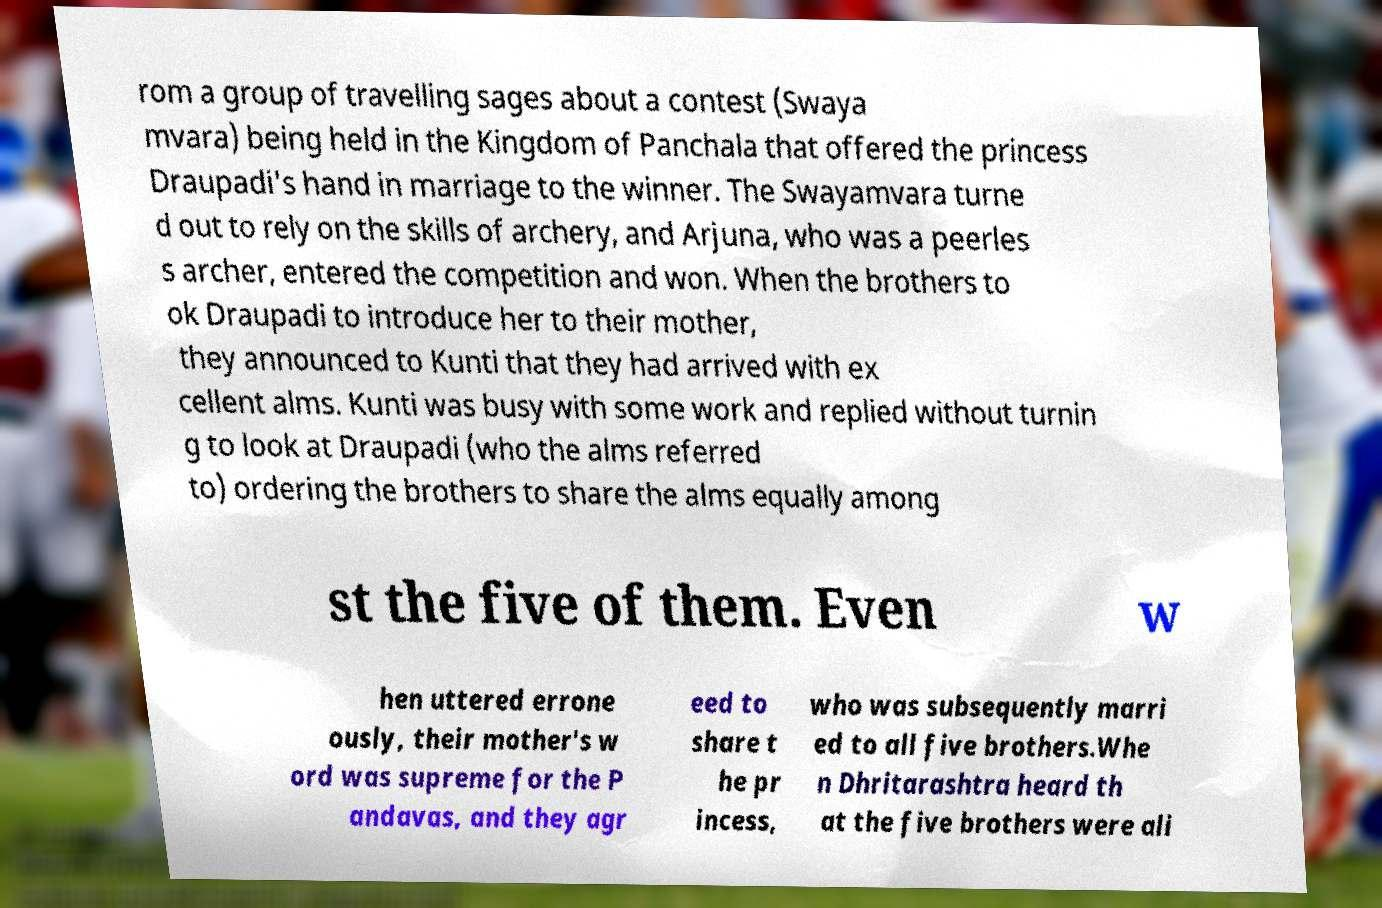Could you assist in decoding the text presented in this image and type it out clearly? rom a group of travelling sages about a contest (Swaya mvara) being held in the Kingdom of Panchala that offered the princess Draupadi's hand in marriage to the winner. The Swayamvara turne d out to rely on the skills of archery, and Arjuna, who was a peerles s archer, entered the competition and won. When the brothers to ok Draupadi to introduce her to their mother, they announced to Kunti that they had arrived with ex cellent alms. Kunti was busy with some work and replied without turnin g to look at Draupadi (who the alms referred to) ordering the brothers to share the alms equally among st the five of them. Even w hen uttered errone ously, their mother's w ord was supreme for the P andavas, and they agr eed to share t he pr incess, who was subsequently marri ed to all five brothers.Whe n Dhritarashtra heard th at the five brothers were ali 